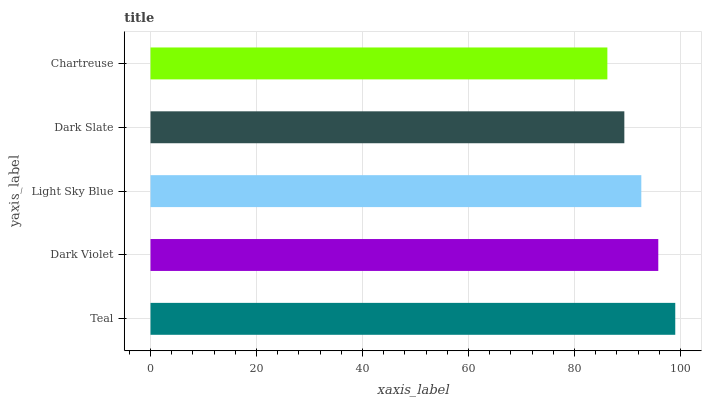Is Chartreuse the minimum?
Answer yes or no. Yes. Is Teal the maximum?
Answer yes or no. Yes. Is Dark Violet the minimum?
Answer yes or no. No. Is Dark Violet the maximum?
Answer yes or no. No. Is Teal greater than Dark Violet?
Answer yes or no. Yes. Is Dark Violet less than Teal?
Answer yes or no. Yes. Is Dark Violet greater than Teal?
Answer yes or no. No. Is Teal less than Dark Violet?
Answer yes or no. No. Is Light Sky Blue the high median?
Answer yes or no. Yes. Is Light Sky Blue the low median?
Answer yes or no. Yes. Is Dark Slate the high median?
Answer yes or no. No. Is Dark Slate the low median?
Answer yes or no. No. 